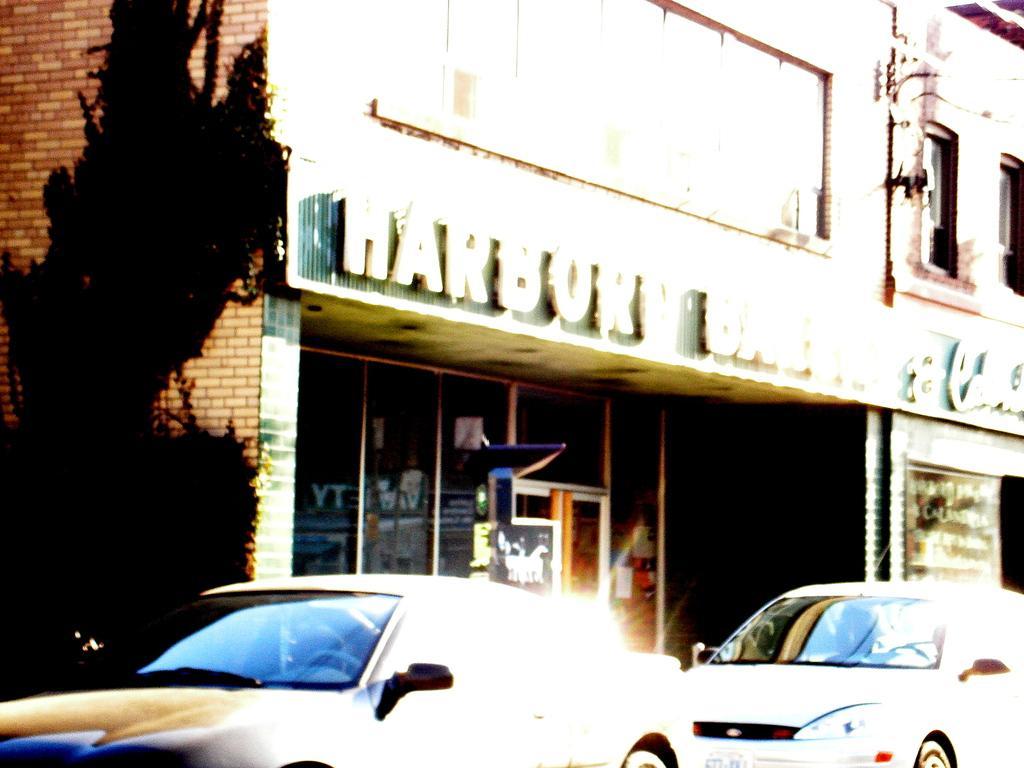How would you summarize this image in a sentence or two? In this image in the middle there is a building, and there is a board attached to the building, on which there is a text, in front of the building there are two vehicles visible at the bottom, on the left side there might be a tree and building wall. 